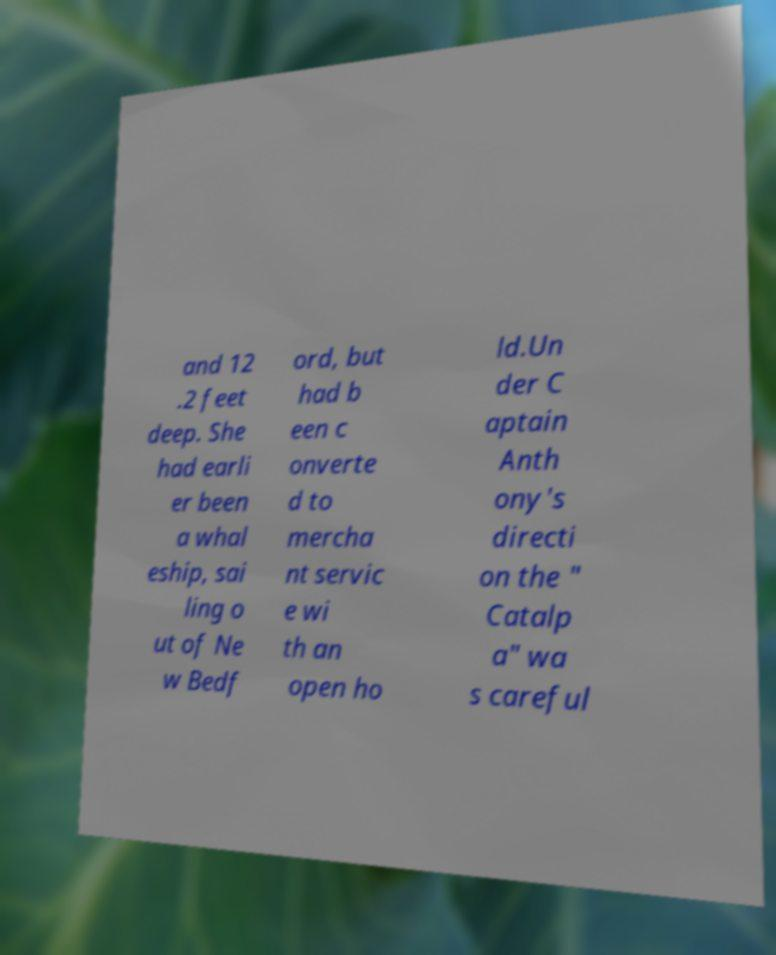Please read and relay the text visible in this image. What does it say? and 12 .2 feet deep. She had earli er been a whal eship, sai ling o ut of Ne w Bedf ord, but had b een c onverte d to mercha nt servic e wi th an open ho ld.Un der C aptain Anth ony's directi on the " Catalp a" wa s careful 